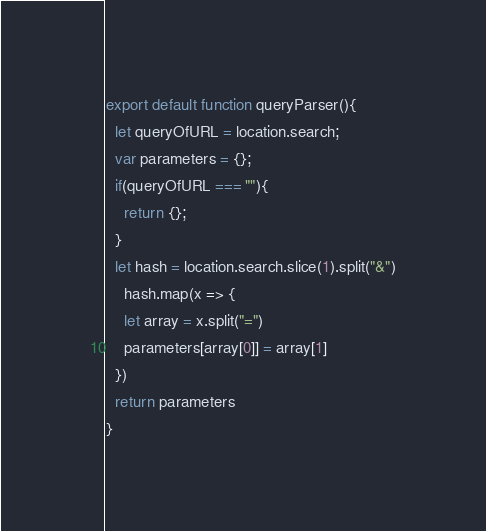<code> <loc_0><loc_0><loc_500><loc_500><_JavaScript_>export default function queryParser(){
  let queryOfURL = location.search;
  var parameters = {};
  if(queryOfURL === ""){
	return {};
  }
  let hash = location.search.slice(1).split("&")
    hash.map(x => {
    let array = x.split("=")
    parameters[array[0]] = array[1]
  })
  return parameters
}
</code> 